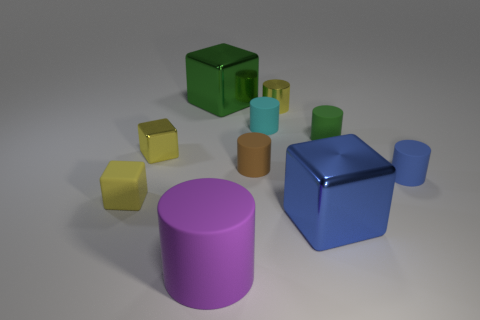Is there a small cube?
Your answer should be compact. Yes. Do the rubber cube and the large metallic cube that is in front of the big green object have the same color?
Give a very brief answer. No. There is another small block that is the same color as the small matte block; what is it made of?
Give a very brief answer. Metal. Is there any other thing that has the same shape as the brown matte object?
Give a very brief answer. Yes. What is the shape of the large shiny thing on the left side of the metal block in front of the small yellow cube that is in front of the small yellow metal cube?
Offer a terse response. Cube. The large purple matte object is what shape?
Offer a very short reply. Cylinder. There is a big shiny cube behind the yellow cylinder; what color is it?
Ensure brevity in your answer.  Green. Do the cube that is to the right of the cyan matte thing and the small blue matte cylinder have the same size?
Offer a very short reply. No. What size is the shiny object that is the same shape as the small blue rubber object?
Provide a succinct answer. Small. Are there any other things that have the same size as the cyan cylinder?
Offer a terse response. Yes. 